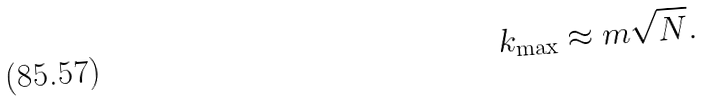Convert formula to latex. <formula><loc_0><loc_0><loc_500><loc_500>k _ { \max } \approx m \sqrt { N } .</formula> 